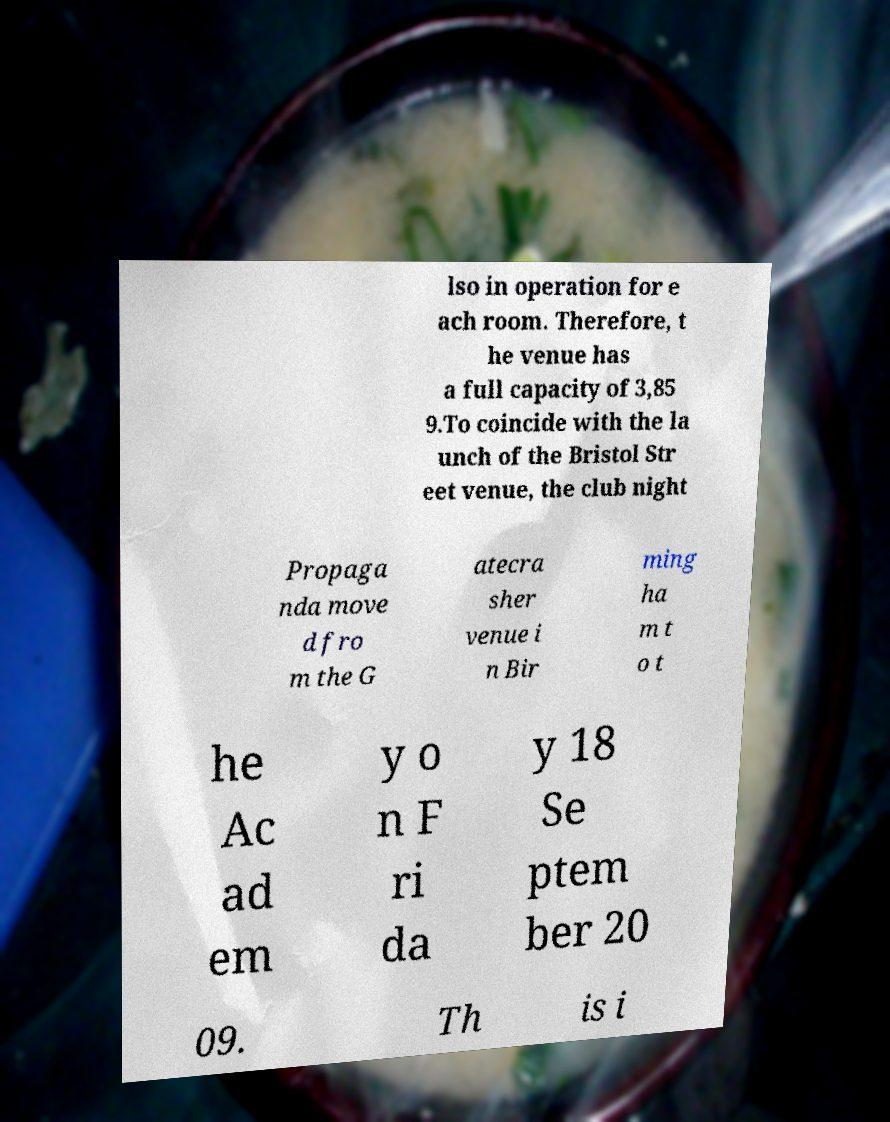Could you assist in decoding the text presented in this image and type it out clearly? lso in operation for e ach room. Therefore, t he venue has a full capacity of 3,85 9.To coincide with the la unch of the Bristol Str eet venue, the club night Propaga nda move d fro m the G atecra sher venue i n Bir ming ha m t o t he Ac ad em y o n F ri da y 18 Se ptem ber 20 09. Th is i 